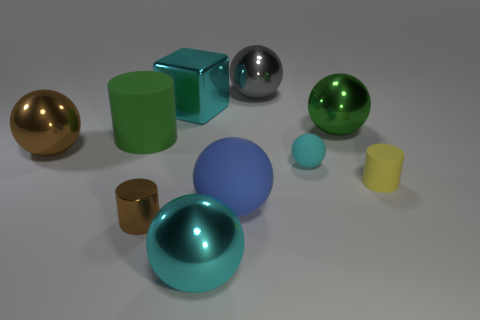Do the small metallic thing left of the large gray shiny thing and the blue rubber object have the same shape?
Provide a succinct answer. No. Does the green shiny object have the same shape as the large gray object?
Your answer should be very brief. Yes. Are there any brown metallic things of the same shape as the big green matte thing?
Offer a very short reply. Yes. The cyan metallic object behind the big cyan metal thing that is to the right of the big metallic cube is what shape?
Your answer should be compact. Cube. There is a big metal thing in front of the yellow object; what is its color?
Offer a very short reply. Cyan. What size is the block that is the same material as the big gray thing?
Make the answer very short. Large. There is a brown object that is the same shape as the yellow matte object; what size is it?
Offer a terse response. Small. Is there a blue shiny block?
Your answer should be compact. No. How many objects are big green metal balls on the right side of the cyan rubber sphere or cylinders?
Provide a succinct answer. 4. What is the material of the gray sphere that is the same size as the brown metallic ball?
Ensure brevity in your answer.  Metal. 